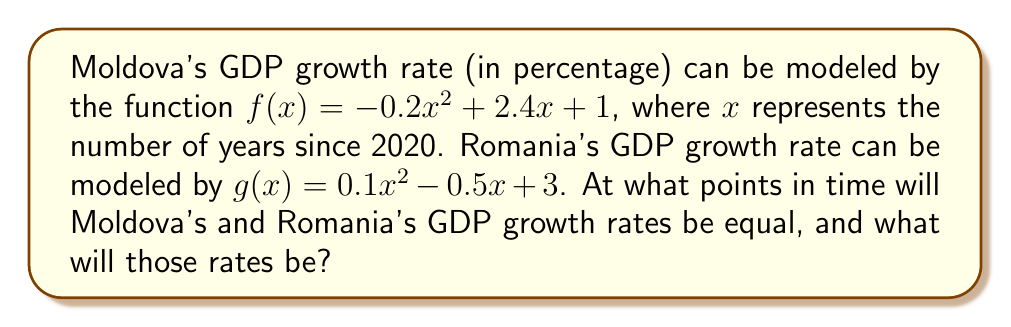Can you answer this question? To find the intersection points of these two functions, we need to set them equal to each other and solve for $x$:

$$f(x) = g(x)$$
$$-0.2x^2 + 2.4x + 1 = 0.1x^2 - 0.5x + 3$$

Rearranging the equation:
$$-0.3x^2 + 2.9x - 2 = 0$$

This is a quadratic equation in the form $ax^2 + bx + c = 0$, where:
$a = -0.3$, $b = 2.9$, and $c = -2$

We can solve this using the quadratic formula: $x = \frac{-b \pm \sqrt{b^2 - 4ac}}{2a}$

$$x = \frac{-2.9 \pm \sqrt{2.9^2 - 4(-0.3)(-2)}}{2(-0.3)}$$
$$x = \frac{-2.9 \pm \sqrt{8.41 - 2.4}}{-0.6}$$
$$x = \frac{-2.9 \pm \sqrt{6.01}}{-0.6}$$
$$x = \frac{-2.9 \pm 2.45}{-0.6}$$

This gives us two solutions:
$$x_1 = \frac{-2.9 + 2.45}{-0.6} = 0.75$$
$$x_2 = \frac{-2.9 - 2.45}{-0.6} = 8.92$$

To find the GDP growth rates at these points, we can substitute either $x$ value into either function:

For $x_1 = 0.75$:
$$f(0.75) = -0.2(0.75)^2 + 2.4(0.75) + 1 = 2.7125$$

For $x_2 = 8.92$:
$$f(8.92) = -0.2(8.92)^2 + 2.4(8.92) + 1 = -3.8912$$

Therefore, the GDP growth rates will be equal after 0.75 years (around 9 months) at a rate of 2.7125%, and again after 8.92 years (about 8 years and 11 months) at a rate of -3.8912%.
Answer: $(0.75, 2.7125)$ and $(8.92, -3.8912)$ 